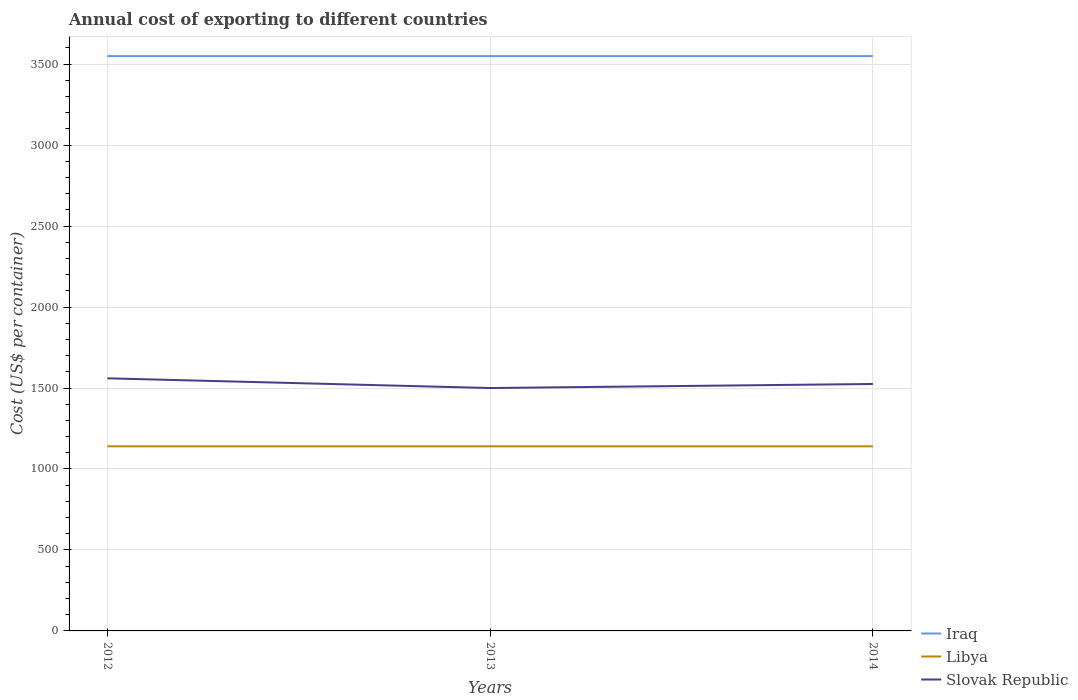How many different coloured lines are there?
Make the answer very short. 3. Across all years, what is the maximum total annual cost of exporting in Libya?
Provide a short and direct response. 1140. What is the total total annual cost of exporting in Slovak Republic in the graph?
Provide a succinct answer. 60. How many years are there in the graph?
Your answer should be compact. 3. How many legend labels are there?
Give a very brief answer. 3. How are the legend labels stacked?
Provide a succinct answer. Vertical. What is the title of the graph?
Your answer should be compact. Annual cost of exporting to different countries. Does "Yemen, Rep." appear as one of the legend labels in the graph?
Provide a succinct answer. No. What is the label or title of the X-axis?
Make the answer very short. Years. What is the label or title of the Y-axis?
Keep it short and to the point. Cost (US$ per container). What is the Cost (US$ per container) in Iraq in 2012?
Offer a terse response. 3550. What is the Cost (US$ per container) in Libya in 2012?
Your answer should be compact. 1140. What is the Cost (US$ per container) of Slovak Republic in 2012?
Offer a very short reply. 1560. What is the Cost (US$ per container) of Iraq in 2013?
Provide a succinct answer. 3550. What is the Cost (US$ per container) in Libya in 2013?
Your answer should be compact. 1140. What is the Cost (US$ per container) in Slovak Republic in 2013?
Your answer should be compact. 1500. What is the Cost (US$ per container) in Iraq in 2014?
Keep it short and to the point. 3550. What is the Cost (US$ per container) in Libya in 2014?
Provide a succinct answer. 1140. What is the Cost (US$ per container) of Slovak Republic in 2014?
Provide a short and direct response. 1525. Across all years, what is the maximum Cost (US$ per container) in Iraq?
Your response must be concise. 3550. Across all years, what is the maximum Cost (US$ per container) in Libya?
Make the answer very short. 1140. Across all years, what is the maximum Cost (US$ per container) in Slovak Republic?
Offer a very short reply. 1560. Across all years, what is the minimum Cost (US$ per container) in Iraq?
Keep it short and to the point. 3550. Across all years, what is the minimum Cost (US$ per container) in Libya?
Your answer should be compact. 1140. Across all years, what is the minimum Cost (US$ per container) in Slovak Republic?
Ensure brevity in your answer.  1500. What is the total Cost (US$ per container) of Iraq in the graph?
Provide a succinct answer. 1.06e+04. What is the total Cost (US$ per container) of Libya in the graph?
Keep it short and to the point. 3420. What is the total Cost (US$ per container) in Slovak Republic in the graph?
Offer a very short reply. 4585. What is the difference between the Cost (US$ per container) of Iraq in 2012 and that in 2013?
Your answer should be compact. 0. What is the difference between the Cost (US$ per container) of Libya in 2012 and that in 2013?
Offer a very short reply. 0. What is the difference between the Cost (US$ per container) in Slovak Republic in 2012 and that in 2013?
Offer a very short reply. 60. What is the difference between the Cost (US$ per container) of Slovak Republic in 2012 and that in 2014?
Make the answer very short. 35. What is the difference between the Cost (US$ per container) of Libya in 2013 and that in 2014?
Your answer should be compact. 0. What is the difference between the Cost (US$ per container) of Slovak Republic in 2013 and that in 2014?
Offer a terse response. -25. What is the difference between the Cost (US$ per container) in Iraq in 2012 and the Cost (US$ per container) in Libya in 2013?
Your answer should be compact. 2410. What is the difference between the Cost (US$ per container) of Iraq in 2012 and the Cost (US$ per container) of Slovak Republic in 2013?
Provide a succinct answer. 2050. What is the difference between the Cost (US$ per container) in Libya in 2012 and the Cost (US$ per container) in Slovak Republic in 2013?
Offer a terse response. -360. What is the difference between the Cost (US$ per container) in Iraq in 2012 and the Cost (US$ per container) in Libya in 2014?
Provide a succinct answer. 2410. What is the difference between the Cost (US$ per container) of Iraq in 2012 and the Cost (US$ per container) of Slovak Republic in 2014?
Ensure brevity in your answer.  2025. What is the difference between the Cost (US$ per container) in Libya in 2012 and the Cost (US$ per container) in Slovak Republic in 2014?
Provide a succinct answer. -385. What is the difference between the Cost (US$ per container) of Iraq in 2013 and the Cost (US$ per container) of Libya in 2014?
Give a very brief answer. 2410. What is the difference between the Cost (US$ per container) in Iraq in 2013 and the Cost (US$ per container) in Slovak Republic in 2014?
Your response must be concise. 2025. What is the difference between the Cost (US$ per container) of Libya in 2013 and the Cost (US$ per container) of Slovak Republic in 2014?
Provide a short and direct response. -385. What is the average Cost (US$ per container) in Iraq per year?
Make the answer very short. 3550. What is the average Cost (US$ per container) of Libya per year?
Give a very brief answer. 1140. What is the average Cost (US$ per container) in Slovak Republic per year?
Provide a short and direct response. 1528.33. In the year 2012, what is the difference between the Cost (US$ per container) in Iraq and Cost (US$ per container) in Libya?
Give a very brief answer. 2410. In the year 2012, what is the difference between the Cost (US$ per container) in Iraq and Cost (US$ per container) in Slovak Republic?
Offer a terse response. 1990. In the year 2012, what is the difference between the Cost (US$ per container) of Libya and Cost (US$ per container) of Slovak Republic?
Provide a succinct answer. -420. In the year 2013, what is the difference between the Cost (US$ per container) of Iraq and Cost (US$ per container) of Libya?
Ensure brevity in your answer.  2410. In the year 2013, what is the difference between the Cost (US$ per container) of Iraq and Cost (US$ per container) of Slovak Republic?
Offer a very short reply. 2050. In the year 2013, what is the difference between the Cost (US$ per container) in Libya and Cost (US$ per container) in Slovak Republic?
Keep it short and to the point. -360. In the year 2014, what is the difference between the Cost (US$ per container) in Iraq and Cost (US$ per container) in Libya?
Ensure brevity in your answer.  2410. In the year 2014, what is the difference between the Cost (US$ per container) of Iraq and Cost (US$ per container) of Slovak Republic?
Ensure brevity in your answer.  2025. In the year 2014, what is the difference between the Cost (US$ per container) of Libya and Cost (US$ per container) of Slovak Republic?
Offer a very short reply. -385. What is the ratio of the Cost (US$ per container) of Libya in 2012 to that in 2014?
Offer a terse response. 1. What is the ratio of the Cost (US$ per container) of Slovak Republic in 2013 to that in 2014?
Provide a succinct answer. 0.98. What is the difference between the highest and the second highest Cost (US$ per container) in Iraq?
Offer a very short reply. 0. What is the difference between the highest and the second highest Cost (US$ per container) in Libya?
Offer a terse response. 0. What is the difference between the highest and the lowest Cost (US$ per container) in Slovak Republic?
Give a very brief answer. 60. 